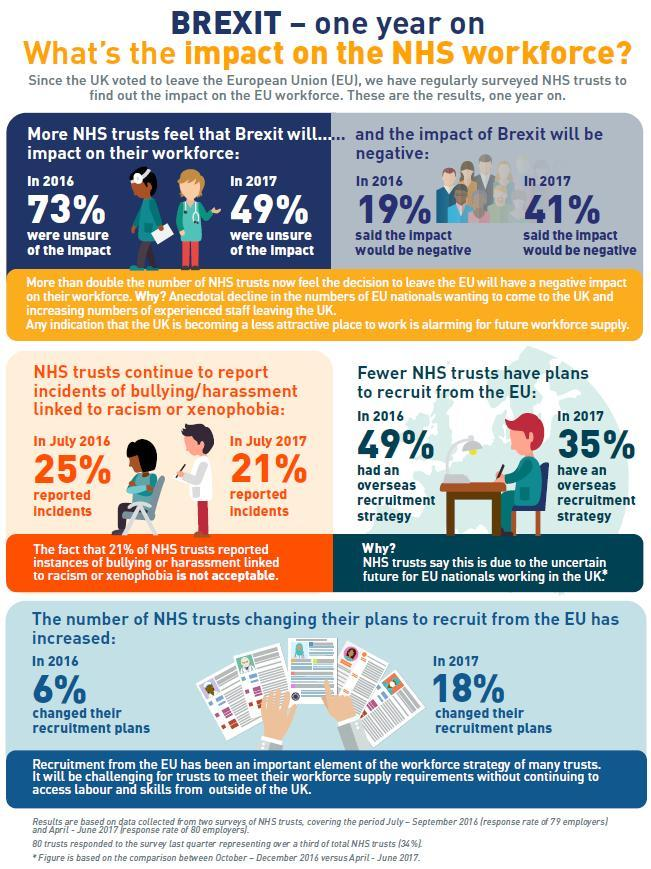What is the percentage increase in  NHS trusts 'changing their recruitment plans' over the year ?
Answer the question with a short phrase. 12% What is the term used here for, UK voting out of the European union ? Brexit In 2016 what percent of the workforce believed that Brexit would have a negative impact ? 19% When compared to 2016, by what percent did overseas recruitment strategy decrease in 2017? 14% What according to the NHS trusts is the reduction in the overseas recruitment strategy  'due to'? Due to the uncertain future for EU nationals working in the UK In 2017 what percent of NHS trusts changed their recruitment plans ? 18% In the final image how many sheets of paper have been spread across ? 5 In 2017 what was the percentage of racism related harassments reported ? 21% 